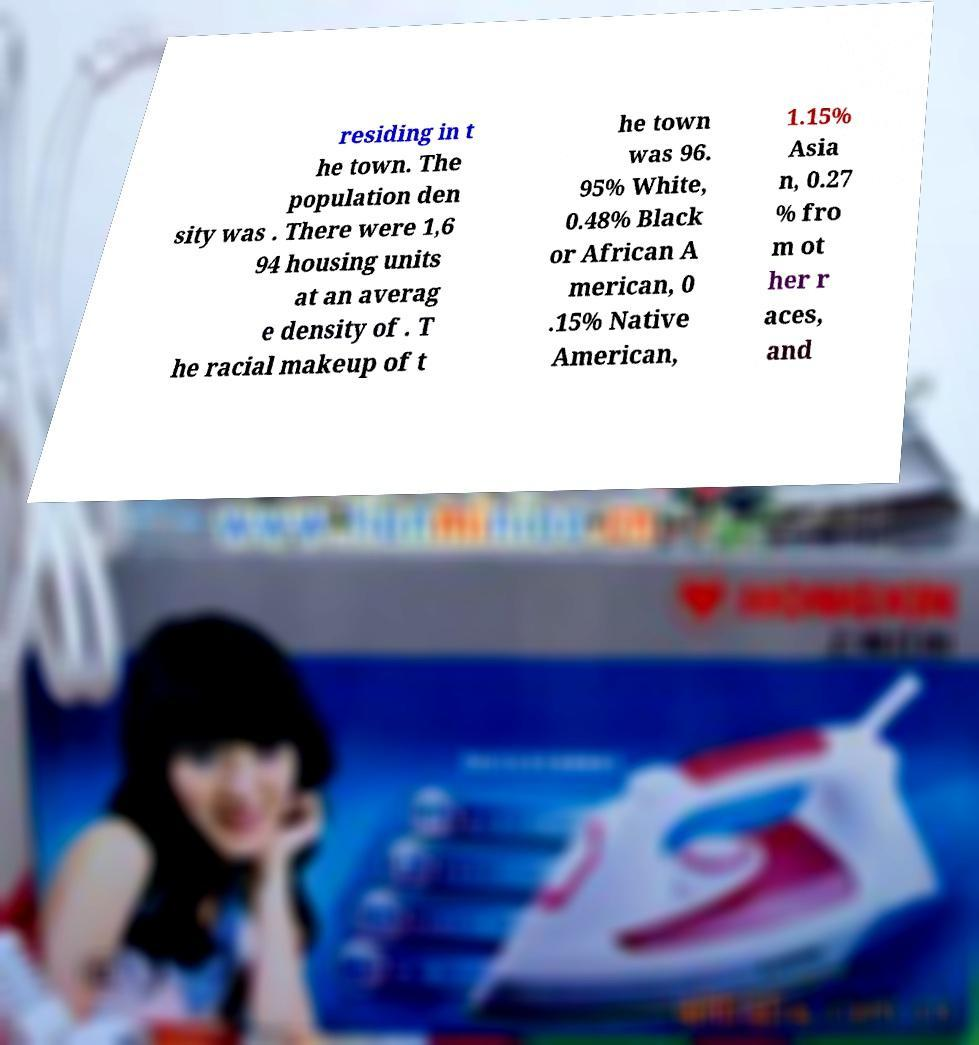Please identify and transcribe the text found in this image. residing in t he town. The population den sity was . There were 1,6 94 housing units at an averag e density of . T he racial makeup of t he town was 96. 95% White, 0.48% Black or African A merican, 0 .15% Native American, 1.15% Asia n, 0.27 % fro m ot her r aces, and 